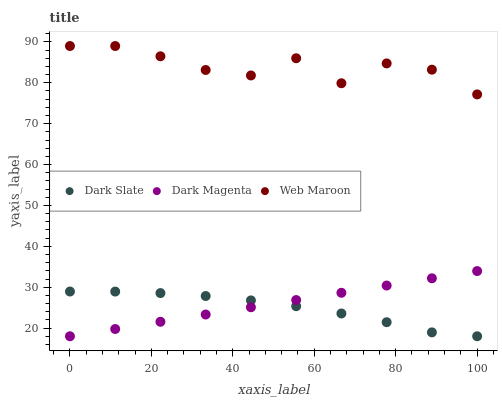Does Dark Slate have the minimum area under the curve?
Answer yes or no. Yes. Does Web Maroon have the maximum area under the curve?
Answer yes or no. Yes. Does Dark Magenta have the minimum area under the curve?
Answer yes or no. No. Does Dark Magenta have the maximum area under the curve?
Answer yes or no. No. Is Dark Magenta the smoothest?
Answer yes or no. Yes. Is Web Maroon the roughest?
Answer yes or no. Yes. Is Web Maroon the smoothest?
Answer yes or no. No. Is Dark Magenta the roughest?
Answer yes or no. No. Does Dark Slate have the lowest value?
Answer yes or no. Yes. Does Web Maroon have the lowest value?
Answer yes or no. No. Does Web Maroon have the highest value?
Answer yes or no. Yes. Does Dark Magenta have the highest value?
Answer yes or no. No. Is Dark Slate less than Web Maroon?
Answer yes or no. Yes. Is Web Maroon greater than Dark Magenta?
Answer yes or no. Yes. Does Dark Magenta intersect Dark Slate?
Answer yes or no. Yes. Is Dark Magenta less than Dark Slate?
Answer yes or no. No. Is Dark Magenta greater than Dark Slate?
Answer yes or no. No. Does Dark Slate intersect Web Maroon?
Answer yes or no. No. 